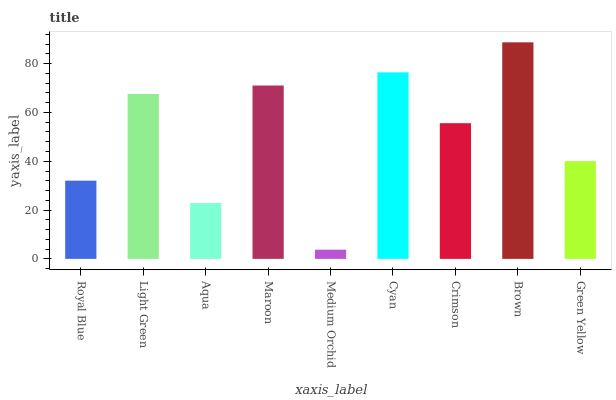Is Medium Orchid the minimum?
Answer yes or no. Yes. Is Brown the maximum?
Answer yes or no. Yes. Is Light Green the minimum?
Answer yes or no. No. Is Light Green the maximum?
Answer yes or no. No. Is Light Green greater than Royal Blue?
Answer yes or no. Yes. Is Royal Blue less than Light Green?
Answer yes or no. Yes. Is Royal Blue greater than Light Green?
Answer yes or no. No. Is Light Green less than Royal Blue?
Answer yes or no. No. Is Crimson the high median?
Answer yes or no. Yes. Is Crimson the low median?
Answer yes or no. Yes. Is Cyan the high median?
Answer yes or no. No. Is Light Green the low median?
Answer yes or no. No. 